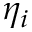<formula> <loc_0><loc_0><loc_500><loc_500>\eta _ { i }</formula> 